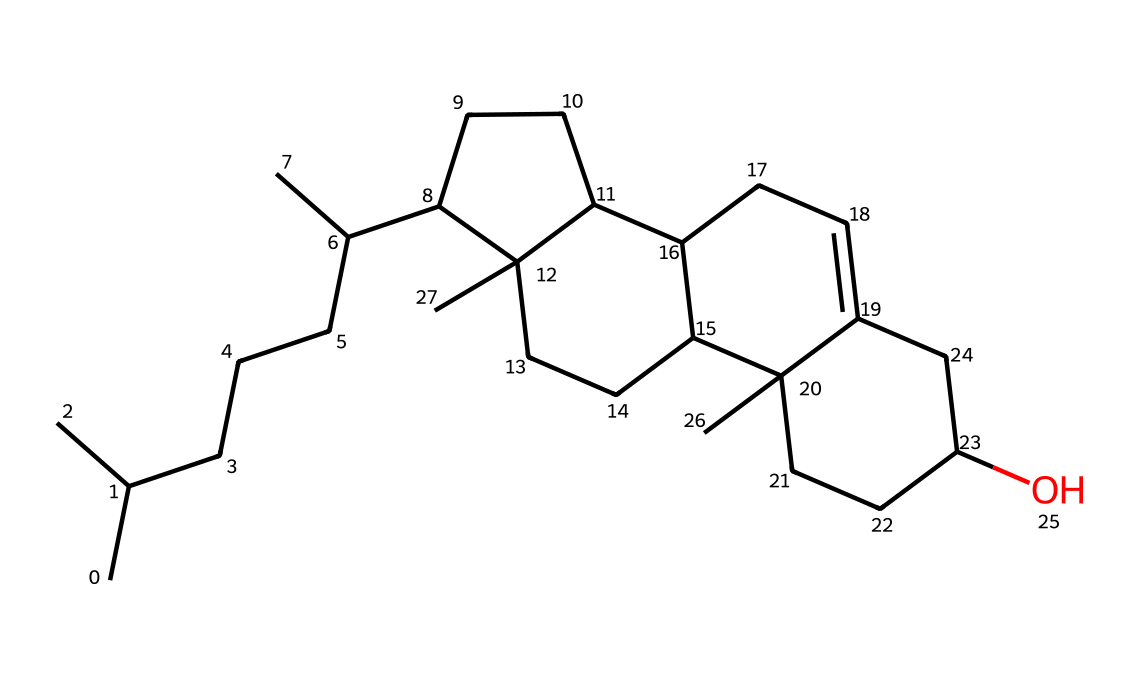What is the molecular formula of cholesterol? By analyzing the provided SMILES representation, we can count the number of carbon, hydrogen, and oxygen atoms. The structure includes a total of 27 carbon atoms, 46 hydrogen atoms, and 1 oxygen atom, leading to the molecular formula C27H46O.
Answer: C27H46O How many rings are present in the cholesterol structure? The structure of cholesterol contains four fused rings, which are typical for steroid lipids. By examining the cyclic portions of the SMILES, we can identify these four distinct ring structures.
Answer: four What functional group is present in cholesterol? There is a hydroxyl group (OH) indicated by the "O" at the end of the SMILES representation. This functional group classifies cholesterol as an alcohol, specifically a steroid alcohol or sterol.
Answer: hydroxyl group What type of lipid is cholesterol classified as? Cholesterol is classified as a sterol, a type of steroid lipid. By reviewing the structure - specifically the fused ring framework - we can conclude it belongs to this particular lipid class.
Answer: sterol How does the presence of cholesterol affect membrane fluidity? Cholesterol modulates membrane fluidity by fitting between phospholipid molecules, which can either stabilize the membrane in high temperatures or maintain fluidity in lower temperatures. This is because its ring structure creates packing that impacts overall membrane characteristics.
Answer: stabilizes How many double bonds are found in the cholesterol structure? In the provided SMILES representation of cholesterol, we can observe that there is only one double bond present. By examining each segment of the structure, we note that the double bond is located within the carbon ring framework.
Answer: one What role does cholesterol play in cellular signaling? Cholesterol acts as a precursor for steroid hormones and is involved in membrane microdomain formation, which is critical for signal transduction. Its presence in membranes affects the localization and movement of signaling proteins within the lipid bilayer.
Answer: signaling modulator 